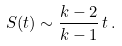<formula> <loc_0><loc_0><loc_500><loc_500>S ( t ) \sim \frac { k - 2 } { k - 1 } \, t \, .</formula> 